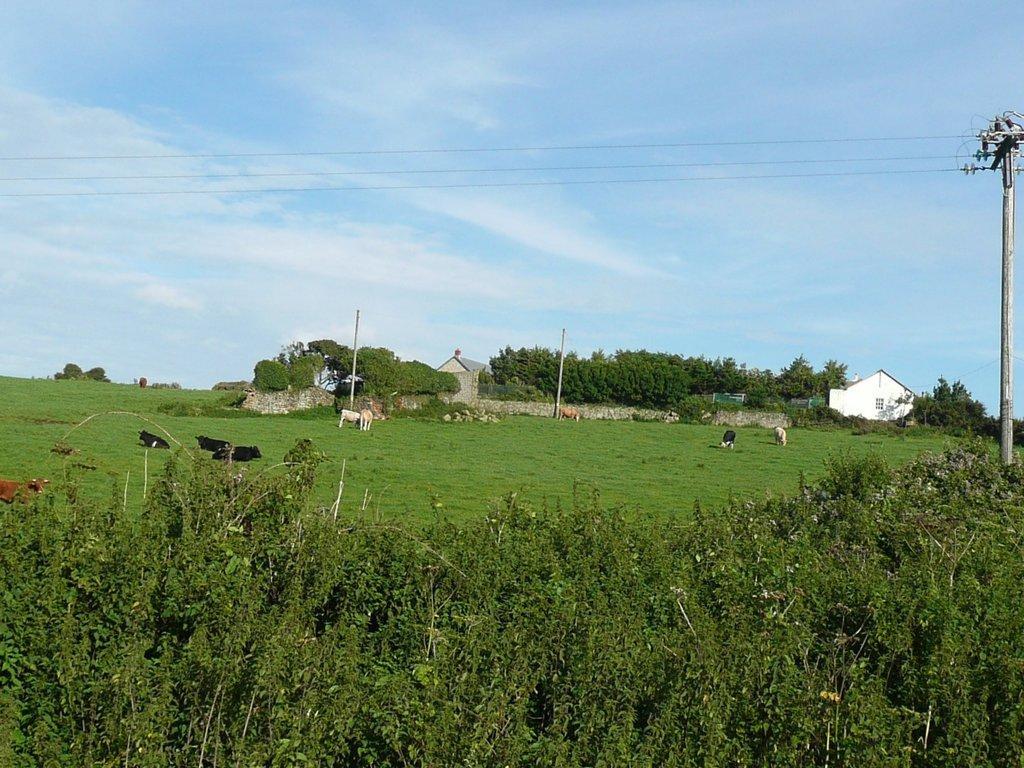Could you give a brief overview of what you see in this image? At the bottom, we see the trees. On the right side, we see an electric pole and wires. In the middle, we see the grass and the cows are grazing the grass. In the background, we see a stone wall, trees, buildings and the poles. At the top, we see the sky and the clouds. 